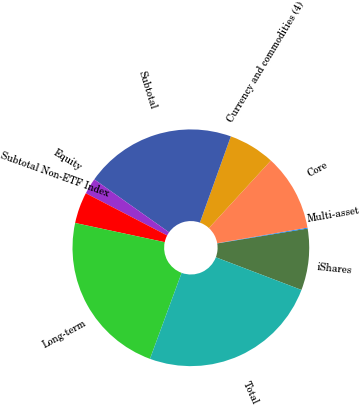<chart> <loc_0><loc_0><loc_500><loc_500><pie_chart><fcel>iShares<fcel>Multi-asset<fcel>Core<fcel>Currency and commodities (4)<fcel>Subtotal<fcel>Equity<fcel>Subtotal Non-ETF Index<fcel>Long-term<fcel>Total<nl><fcel>8.4%<fcel>0.12%<fcel>10.47%<fcel>6.33%<fcel>20.68%<fcel>2.19%<fcel>4.26%<fcel>22.75%<fcel>24.82%<nl></chart> 